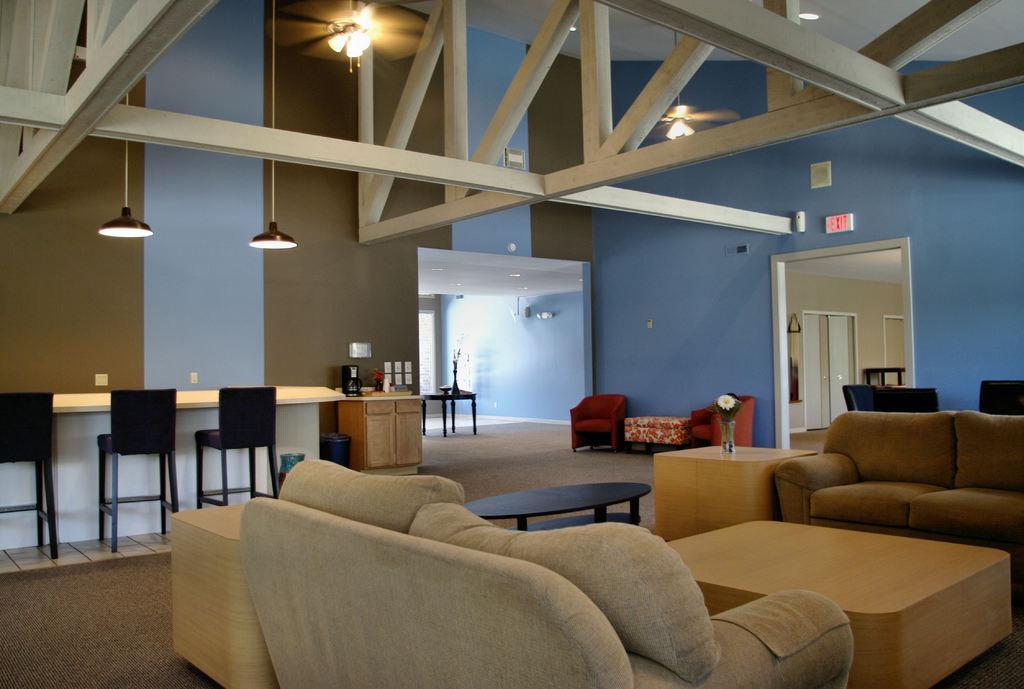Could you give a brief overview of what you see in this image? In this image I can see a hall with couch,teapoy,chairs,flower vase,lights,cupboard and the table. 